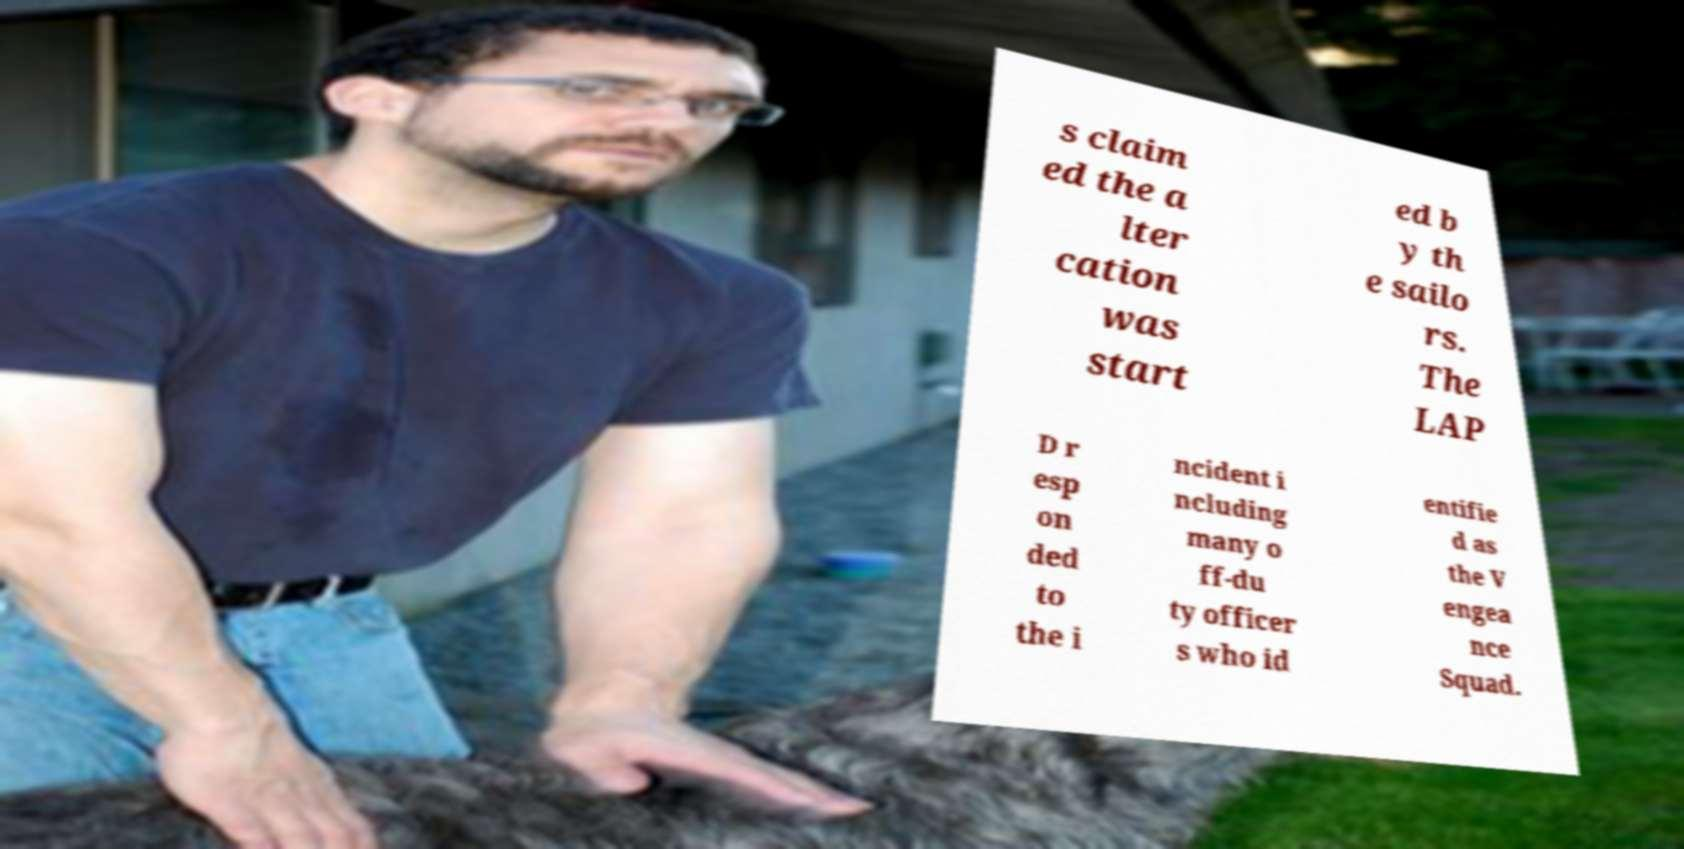Can you accurately transcribe the text from the provided image for me? s claim ed the a lter cation was start ed b y th e sailo rs. The LAP D r esp on ded to the i ncident i ncluding many o ff-du ty officer s who id entifie d as the V engea nce Squad. 